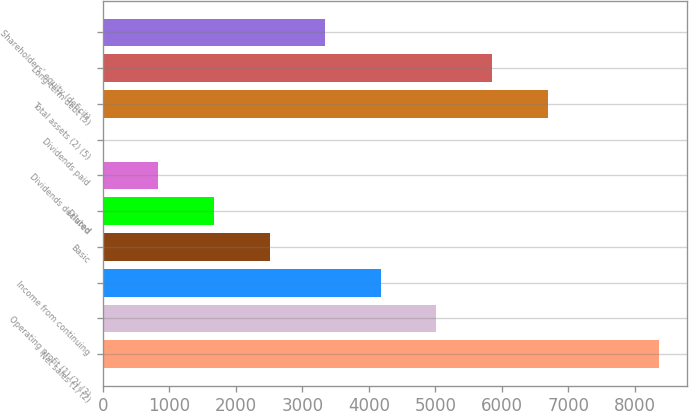Convert chart. <chart><loc_0><loc_0><loc_500><loc_500><bar_chart><fcel>Net sales (1) (2)<fcel>Operating profit (1) (2) (3)<fcel>Income from continuing<fcel>Basic<fcel>Diluted<fcel>Dividends declared<fcel>Dividends paid<fcel>Total assets (2) (5)<fcel>Long-term debt (5)<fcel>Shareholders' equity (deficit)<nl><fcel>8359<fcel>5015.59<fcel>4179.73<fcel>2508.01<fcel>1672.15<fcel>836.29<fcel>0.43<fcel>6687.31<fcel>5851.45<fcel>3343.87<nl></chart> 